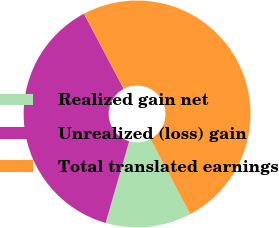<chart> <loc_0><loc_0><loc_500><loc_500><pie_chart><fcel>Realized gain net<fcel>Unrealized (loss) gain<fcel>Total translated earnings<nl><fcel>12.23%<fcel>37.77%<fcel>50.0%<nl></chart> 